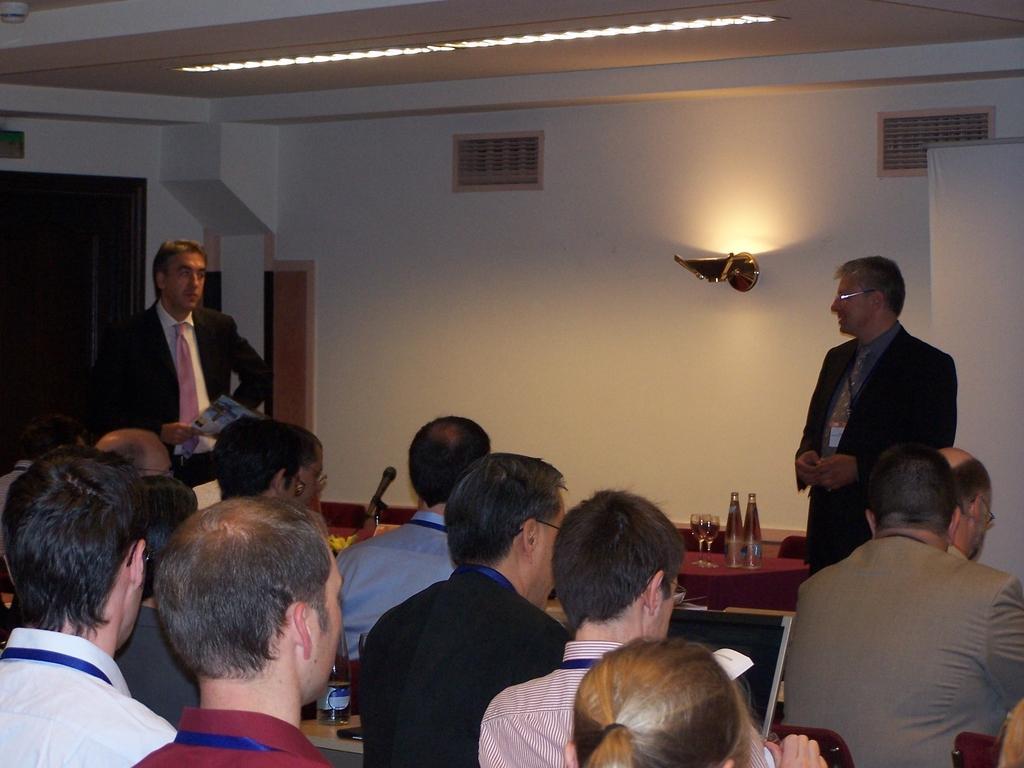Describe this image in one or two sentences. In this image I see number of people who are sitting on the chairs and there are tables in front of them and on the tables I see laptop, bottles, glasses and a mic. I can also see this 2 men are standing. In the background I see the wall, vents and the light. 